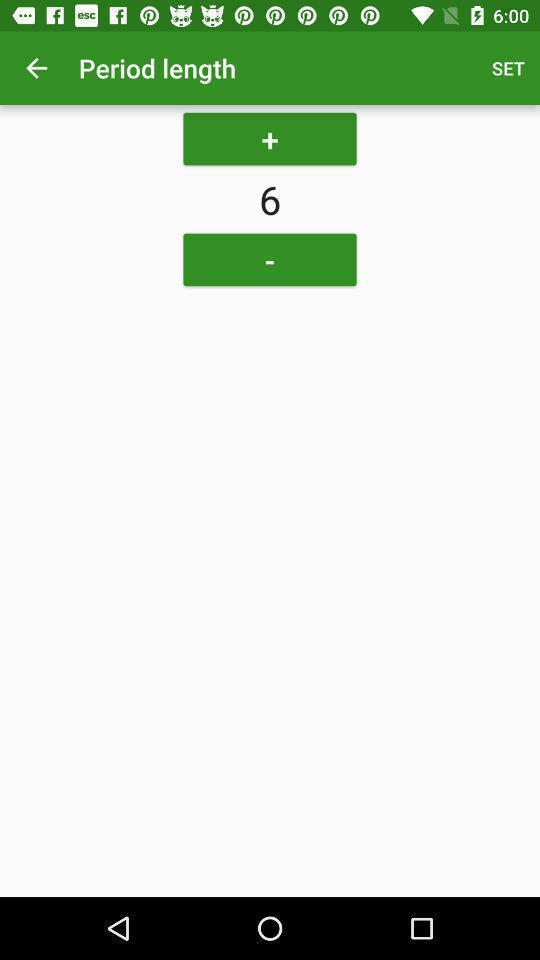Tell me about the visual elements in this screen capture. Screen shows period length details in a health app. 